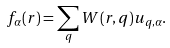<formula> <loc_0><loc_0><loc_500><loc_500>f _ { \alpha } ( { r } ) = \sum _ { q } W ( { r } , { q } ) u _ { { q } , \alpha } .</formula> 